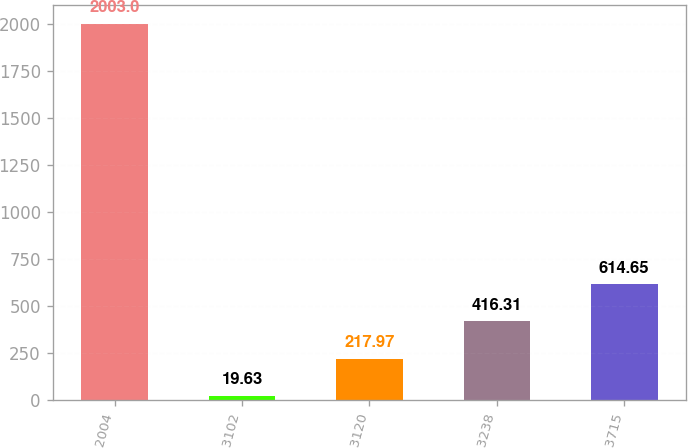Convert chart to OTSL. <chart><loc_0><loc_0><loc_500><loc_500><bar_chart><fcel>2004<fcel>3102<fcel>3120<fcel>3238<fcel>3715<nl><fcel>2003<fcel>19.63<fcel>217.97<fcel>416.31<fcel>614.65<nl></chart> 